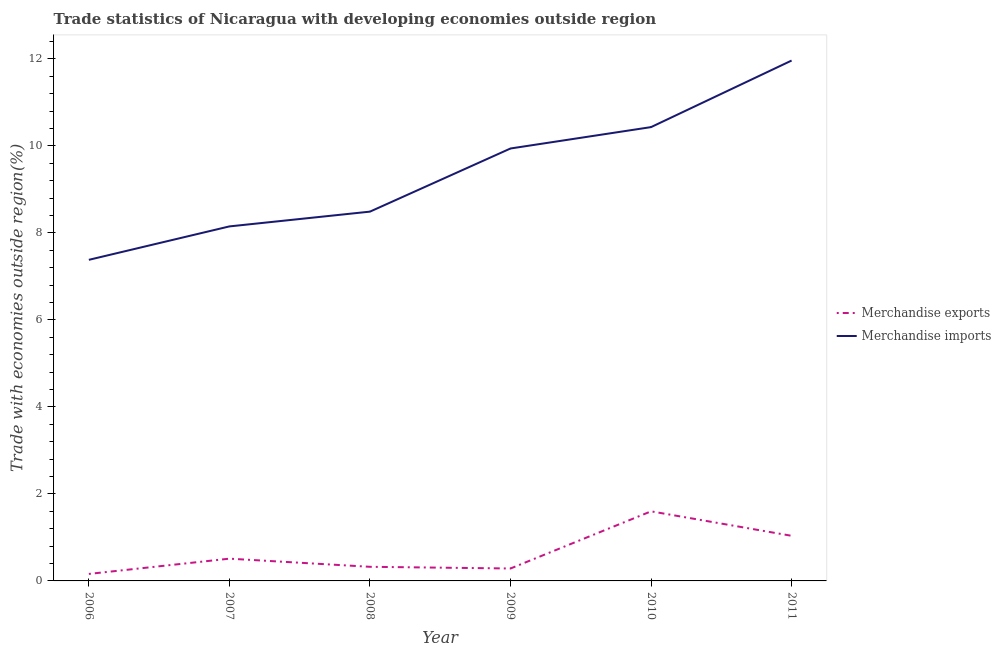Is the number of lines equal to the number of legend labels?
Keep it short and to the point. Yes. What is the merchandise exports in 2011?
Offer a very short reply. 1.04. Across all years, what is the maximum merchandise imports?
Give a very brief answer. 11.96. Across all years, what is the minimum merchandise exports?
Make the answer very short. 0.16. What is the total merchandise imports in the graph?
Make the answer very short. 56.35. What is the difference between the merchandise imports in 2007 and that in 2008?
Keep it short and to the point. -0.34. What is the difference between the merchandise exports in 2007 and the merchandise imports in 2008?
Make the answer very short. -7.98. What is the average merchandise imports per year?
Ensure brevity in your answer.  9.39. In the year 2008, what is the difference between the merchandise imports and merchandise exports?
Offer a very short reply. 8.16. What is the ratio of the merchandise imports in 2008 to that in 2011?
Your answer should be compact. 0.71. What is the difference between the highest and the second highest merchandise exports?
Your response must be concise. 0.56. What is the difference between the highest and the lowest merchandise exports?
Provide a succinct answer. 1.44. In how many years, is the merchandise imports greater than the average merchandise imports taken over all years?
Offer a very short reply. 3. Is the merchandise exports strictly greater than the merchandise imports over the years?
Provide a succinct answer. No. How many lines are there?
Ensure brevity in your answer.  2. What is the difference between two consecutive major ticks on the Y-axis?
Offer a very short reply. 2. Are the values on the major ticks of Y-axis written in scientific E-notation?
Keep it short and to the point. No. Does the graph contain any zero values?
Keep it short and to the point. No. Does the graph contain grids?
Provide a succinct answer. No. Where does the legend appear in the graph?
Make the answer very short. Center right. How many legend labels are there?
Offer a terse response. 2. How are the legend labels stacked?
Provide a short and direct response. Vertical. What is the title of the graph?
Offer a very short reply. Trade statistics of Nicaragua with developing economies outside region. Does "Pregnant women" appear as one of the legend labels in the graph?
Give a very brief answer. No. What is the label or title of the Y-axis?
Your answer should be very brief. Trade with economies outside region(%). What is the Trade with economies outside region(%) of Merchandise exports in 2006?
Provide a short and direct response. 0.16. What is the Trade with economies outside region(%) in Merchandise imports in 2006?
Provide a short and direct response. 7.38. What is the Trade with economies outside region(%) of Merchandise exports in 2007?
Provide a succinct answer. 0.51. What is the Trade with economies outside region(%) of Merchandise imports in 2007?
Give a very brief answer. 8.15. What is the Trade with economies outside region(%) of Merchandise exports in 2008?
Provide a short and direct response. 0.32. What is the Trade with economies outside region(%) of Merchandise imports in 2008?
Ensure brevity in your answer.  8.49. What is the Trade with economies outside region(%) in Merchandise exports in 2009?
Provide a succinct answer. 0.29. What is the Trade with economies outside region(%) of Merchandise imports in 2009?
Your answer should be very brief. 9.94. What is the Trade with economies outside region(%) of Merchandise exports in 2010?
Keep it short and to the point. 1.6. What is the Trade with economies outside region(%) in Merchandise imports in 2010?
Offer a very short reply. 10.43. What is the Trade with economies outside region(%) in Merchandise exports in 2011?
Keep it short and to the point. 1.04. What is the Trade with economies outside region(%) in Merchandise imports in 2011?
Keep it short and to the point. 11.96. Across all years, what is the maximum Trade with economies outside region(%) of Merchandise exports?
Make the answer very short. 1.6. Across all years, what is the maximum Trade with economies outside region(%) of Merchandise imports?
Keep it short and to the point. 11.96. Across all years, what is the minimum Trade with economies outside region(%) in Merchandise exports?
Your response must be concise. 0.16. Across all years, what is the minimum Trade with economies outside region(%) of Merchandise imports?
Make the answer very short. 7.38. What is the total Trade with economies outside region(%) of Merchandise exports in the graph?
Provide a succinct answer. 3.92. What is the total Trade with economies outside region(%) of Merchandise imports in the graph?
Keep it short and to the point. 56.35. What is the difference between the Trade with economies outside region(%) in Merchandise exports in 2006 and that in 2007?
Provide a short and direct response. -0.35. What is the difference between the Trade with economies outside region(%) of Merchandise imports in 2006 and that in 2007?
Offer a terse response. -0.77. What is the difference between the Trade with economies outside region(%) in Merchandise exports in 2006 and that in 2008?
Your answer should be compact. -0.16. What is the difference between the Trade with economies outside region(%) of Merchandise imports in 2006 and that in 2008?
Your answer should be very brief. -1.11. What is the difference between the Trade with economies outside region(%) in Merchandise exports in 2006 and that in 2009?
Offer a terse response. -0.12. What is the difference between the Trade with economies outside region(%) of Merchandise imports in 2006 and that in 2009?
Provide a short and direct response. -2.56. What is the difference between the Trade with economies outside region(%) of Merchandise exports in 2006 and that in 2010?
Ensure brevity in your answer.  -1.44. What is the difference between the Trade with economies outside region(%) in Merchandise imports in 2006 and that in 2010?
Provide a short and direct response. -3.05. What is the difference between the Trade with economies outside region(%) in Merchandise exports in 2006 and that in 2011?
Ensure brevity in your answer.  -0.88. What is the difference between the Trade with economies outside region(%) of Merchandise imports in 2006 and that in 2011?
Ensure brevity in your answer.  -4.58. What is the difference between the Trade with economies outside region(%) of Merchandise exports in 2007 and that in 2008?
Provide a succinct answer. 0.19. What is the difference between the Trade with economies outside region(%) of Merchandise imports in 2007 and that in 2008?
Offer a very short reply. -0.34. What is the difference between the Trade with economies outside region(%) of Merchandise exports in 2007 and that in 2009?
Keep it short and to the point. 0.23. What is the difference between the Trade with economies outside region(%) of Merchandise imports in 2007 and that in 2009?
Provide a short and direct response. -1.79. What is the difference between the Trade with economies outside region(%) of Merchandise exports in 2007 and that in 2010?
Your answer should be very brief. -1.09. What is the difference between the Trade with economies outside region(%) in Merchandise imports in 2007 and that in 2010?
Your answer should be very brief. -2.28. What is the difference between the Trade with economies outside region(%) in Merchandise exports in 2007 and that in 2011?
Offer a very short reply. -0.53. What is the difference between the Trade with economies outside region(%) of Merchandise imports in 2007 and that in 2011?
Your answer should be very brief. -3.81. What is the difference between the Trade with economies outside region(%) of Merchandise exports in 2008 and that in 2009?
Keep it short and to the point. 0.04. What is the difference between the Trade with economies outside region(%) in Merchandise imports in 2008 and that in 2009?
Provide a short and direct response. -1.45. What is the difference between the Trade with economies outside region(%) of Merchandise exports in 2008 and that in 2010?
Make the answer very short. -1.27. What is the difference between the Trade with economies outside region(%) of Merchandise imports in 2008 and that in 2010?
Give a very brief answer. -1.94. What is the difference between the Trade with economies outside region(%) in Merchandise exports in 2008 and that in 2011?
Keep it short and to the point. -0.71. What is the difference between the Trade with economies outside region(%) of Merchandise imports in 2008 and that in 2011?
Give a very brief answer. -3.47. What is the difference between the Trade with economies outside region(%) of Merchandise exports in 2009 and that in 2010?
Offer a very short reply. -1.31. What is the difference between the Trade with economies outside region(%) of Merchandise imports in 2009 and that in 2010?
Provide a short and direct response. -0.49. What is the difference between the Trade with economies outside region(%) in Merchandise exports in 2009 and that in 2011?
Offer a very short reply. -0.75. What is the difference between the Trade with economies outside region(%) of Merchandise imports in 2009 and that in 2011?
Make the answer very short. -2.02. What is the difference between the Trade with economies outside region(%) in Merchandise exports in 2010 and that in 2011?
Your response must be concise. 0.56. What is the difference between the Trade with economies outside region(%) of Merchandise imports in 2010 and that in 2011?
Offer a very short reply. -1.53. What is the difference between the Trade with economies outside region(%) in Merchandise exports in 2006 and the Trade with economies outside region(%) in Merchandise imports in 2007?
Keep it short and to the point. -7.99. What is the difference between the Trade with economies outside region(%) in Merchandise exports in 2006 and the Trade with economies outside region(%) in Merchandise imports in 2008?
Give a very brief answer. -8.33. What is the difference between the Trade with economies outside region(%) of Merchandise exports in 2006 and the Trade with economies outside region(%) of Merchandise imports in 2009?
Ensure brevity in your answer.  -9.78. What is the difference between the Trade with economies outside region(%) of Merchandise exports in 2006 and the Trade with economies outside region(%) of Merchandise imports in 2010?
Provide a short and direct response. -10.27. What is the difference between the Trade with economies outside region(%) in Merchandise exports in 2006 and the Trade with economies outside region(%) in Merchandise imports in 2011?
Ensure brevity in your answer.  -11.8. What is the difference between the Trade with economies outside region(%) of Merchandise exports in 2007 and the Trade with economies outside region(%) of Merchandise imports in 2008?
Your answer should be compact. -7.98. What is the difference between the Trade with economies outside region(%) in Merchandise exports in 2007 and the Trade with economies outside region(%) in Merchandise imports in 2009?
Offer a very short reply. -9.43. What is the difference between the Trade with economies outside region(%) of Merchandise exports in 2007 and the Trade with economies outside region(%) of Merchandise imports in 2010?
Make the answer very short. -9.92. What is the difference between the Trade with economies outside region(%) in Merchandise exports in 2007 and the Trade with economies outside region(%) in Merchandise imports in 2011?
Give a very brief answer. -11.45. What is the difference between the Trade with economies outside region(%) of Merchandise exports in 2008 and the Trade with economies outside region(%) of Merchandise imports in 2009?
Offer a very short reply. -9.61. What is the difference between the Trade with economies outside region(%) in Merchandise exports in 2008 and the Trade with economies outside region(%) in Merchandise imports in 2010?
Make the answer very short. -10.11. What is the difference between the Trade with economies outside region(%) of Merchandise exports in 2008 and the Trade with economies outside region(%) of Merchandise imports in 2011?
Ensure brevity in your answer.  -11.64. What is the difference between the Trade with economies outside region(%) in Merchandise exports in 2009 and the Trade with economies outside region(%) in Merchandise imports in 2010?
Make the answer very short. -10.14. What is the difference between the Trade with economies outside region(%) of Merchandise exports in 2009 and the Trade with economies outside region(%) of Merchandise imports in 2011?
Your response must be concise. -11.68. What is the difference between the Trade with economies outside region(%) in Merchandise exports in 2010 and the Trade with economies outside region(%) in Merchandise imports in 2011?
Provide a short and direct response. -10.36. What is the average Trade with economies outside region(%) of Merchandise exports per year?
Provide a short and direct response. 0.65. What is the average Trade with economies outside region(%) in Merchandise imports per year?
Give a very brief answer. 9.39. In the year 2006, what is the difference between the Trade with economies outside region(%) of Merchandise exports and Trade with economies outside region(%) of Merchandise imports?
Provide a short and direct response. -7.22. In the year 2007, what is the difference between the Trade with economies outside region(%) of Merchandise exports and Trade with economies outside region(%) of Merchandise imports?
Provide a short and direct response. -7.64. In the year 2008, what is the difference between the Trade with economies outside region(%) in Merchandise exports and Trade with economies outside region(%) in Merchandise imports?
Make the answer very short. -8.16. In the year 2009, what is the difference between the Trade with economies outside region(%) in Merchandise exports and Trade with economies outside region(%) in Merchandise imports?
Your answer should be very brief. -9.65. In the year 2010, what is the difference between the Trade with economies outside region(%) of Merchandise exports and Trade with economies outside region(%) of Merchandise imports?
Your answer should be very brief. -8.83. In the year 2011, what is the difference between the Trade with economies outside region(%) of Merchandise exports and Trade with economies outside region(%) of Merchandise imports?
Your answer should be compact. -10.92. What is the ratio of the Trade with economies outside region(%) in Merchandise exports in 2006 to that in 2007?
Offer a very short reply. 0.31. What is the ratio of the Trade with economies outside region(%) of Merchandise imports in 2006 to that in 2007?
Make the answer very short. 0.91. What is the ratio of the Trade with economies outside region(%) of Merchandise exports in 2006 to that in 2008?
Offer a very short reply. 0.5. What is the ratio of the Trade with economies outside region(%) of Merchandise imports in 2006 to that in 2008?
Provide a succinct answer. 0.87. What is the ratio of the Trade with economies outside region(%) in Merchandise exports in 2006 to that in 2009?
Provide a succinct answer. 0.56. What is the ratio of the Trade with economies outside region(%) of Merchandise imports in 2006 to that in 2009?
Your answer should be very brief. 0.74. What is the ratio of the Trade with economies outside region(%) in Merchandise exports in 2006 to that in 2010?
Make the answer very short. 0.1. What is the ratio of the Trade with economies outside region(%) of Merchandise imports in 2006 to that in 2010?
Give a very brief answer. 0.71. What is the ratio of the Trade with economies outside region(%) of Merchandise exports in 2006 to that in 2011?
Ensure brevity in your answer.  0.15. What is the ratio of the Trade with economies outside region(%) of Merchandise imports in 2006 to that in 2011?
Make the answer very short. 0.62. What is the ratio of the Trade with economies outside region(%) of Merchandise exports in 2007 to that in 2008?
Provide a succinct answer. 1.58. What is the ratio of the Trade with economies outside region(%) of Merchandise exports in 2007 to that in 2009?
Offer a very short reply. 1.79. What is the ratio of the Trade with economies outside region(%) in Merchandise imports in 2007 to that in 2009?
Ensure brevity in your answer.  0.82. What is the ratio of the Trade with economies outside region(%) of Merchandise exports in 2007 to that in 2010?
Make the answer very short. 0.32. What is the ratio of the Trade with economies outside region(%) in Merchandise imports in 2007 to that in 2010?
Offer a terse response. 0.78. What is the ratio of the Trade with economies outside region(%) of Merchandise exports in 2007 to that in 2011?
Your answer should be compact. 0.49. What is the ratio of the Trade with economies outside region(%) of Merchandise imports in 2007 to that in 2011?
Your answer should be very brief. 0.68. What is the ratio of the Trade with economies outside region(%) of Merchandise exports in 2008 to that in 2009?
Your answer should be compact. 1.14. What is the ratio of the Trade with economies outside region(%) of Merchandise imports in 2008 to that in 2009?
Your answer should be compact. 0.85. What is the ratio of the Trade with economies outside region(%) of Merchandise exports in 2008 to that in 2010?
Offer a terse response. 0.2. What is the ratio of the Trade with economies outside region(%) of Merchandise imports in 2008 to that in 2010?
Offer a terse response. 0.81. What is the ratio of the Trade with economies outside region(%) in Merchandise exports in 2008 to that in 2011?
Your response must be concise. 0.31. What is the ratio of the Trade with economies outside region(%) of Merchandise imports in 2008 to that in 2011?
Offer a very short reply. 0.71. What is the ratio of the Trade with economies outside region(%) of Merchandise exports in 2009 to that in 2010?
Offer a very short reply. 0.18. What is the ratio of the Trade with economies outside region(%) in Merchandise imports in 2009 to that in 2010?
Keep it short and to the point. 0.95. What is the ratio of the Trade with economies outside region(%) in Merchandise exports in 2009 to that in 2011?
Offer a terse response. 0.28. What is the ratio of the Trade with economies outside region(%) of Merchandise imports in 2009 to that in 2011?
Give a very brief answer. 0.83. What is the ratio of the Trade with economies outside region(%) in Merchandise exports in 2010 to that in 2011?
Provide a succinct answer. 1.54. What is the ratio of the Trade with economies outside region(%) of Merchandise imports in 2010 to that in 2011?
Offer a very short reply. 0.87. What is the difference between the highest and the second highest Trade with economies outside region(%) in Merchandise exports?
Provide a succinct answer. 0.56. What is the difference between the highest and the second highest Trade with economies outside region(%) of Merchandise imports?
Offer a very short reply. 1.53. What is the difference between the highest and the lowest Trade with economies outside region(%) in Merchandise exports?
Offer a terse response. 1.44. What is the difference between the highest and the lowest Trade with economies outside region(%) of Merchandise imports?
Make the answer very short. 4.58. 